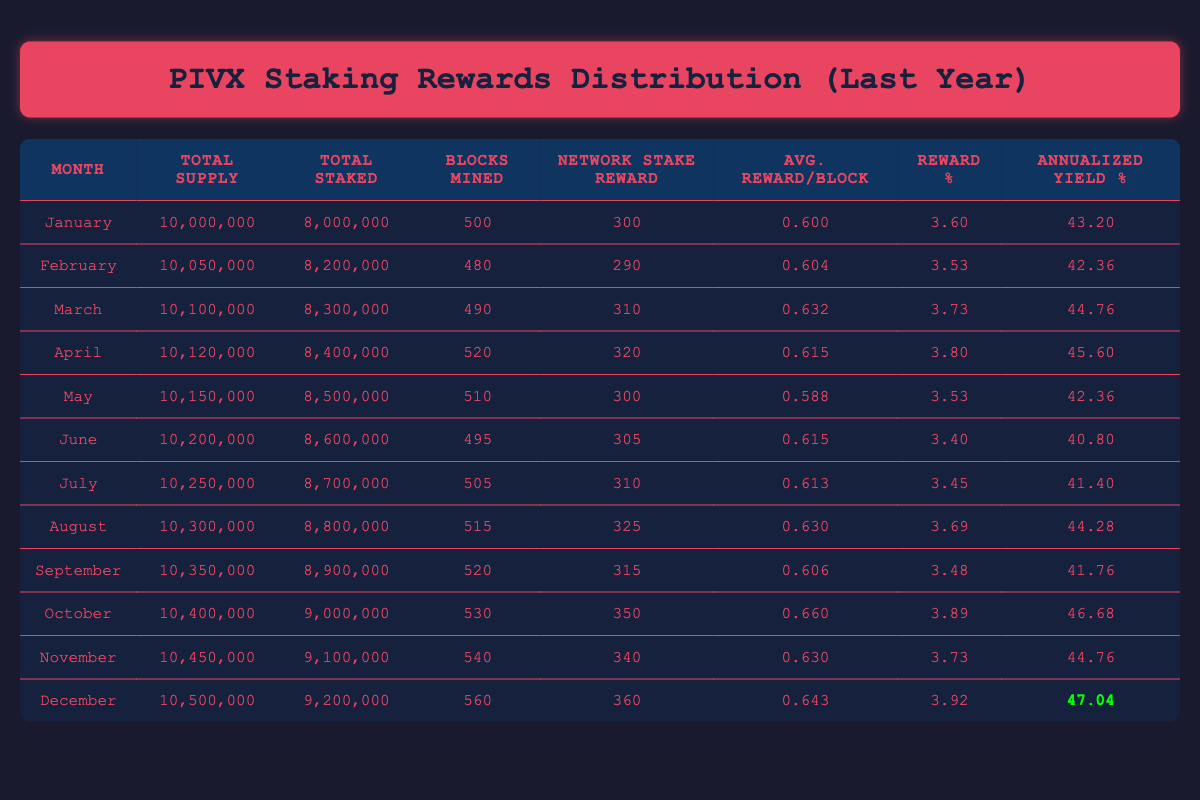What was the total supply of PIVX in December? Referring to the table, the total supply for December is directly listed under the "Total Supply" column, which shows 10,500,000.
Answer: 10,500,000 In which month did PIVX have the highest average reward per block? By checking the "Avg. Reward/Block" column for each month, October has the highest value of 0.660.
Answer: October What is the average annualized yield across all months? To find this, sum the "Annualized Yield %" values: 43.20 + 42.36 + 44.76 + 45.60 + 42.36 + 40.80 + 41.40 + 44.28 + 41.76 + 46.68 + 44.76 + 47.04 = 513.36. Then divide by 12 to get the average: 513.36 / 12 = 42.78.
Answer: 42.78 Did the network stake reward decrease from January to February? In January, the network stake reward was 300, while in February, it was 290. Therefore, it did decrease from one month to the next.
Answer: Yes How many blocks were mined in the month with the lowest reward percentage? The lowest "Reward %" value is in June, with 3.40%. In that same month, 495 blocks were mined.
Answer: 495 Which month had the highest total staked amount? The "Total Staked" column shows a steady increase throughout the year, and December has the highest amount at 9,200,000.
Answer: December What is the difference in total supply between January and December? The total supply in January is 10,000,000 and in December is 10,500,000. Therefore, the difference is 10,500,000 - 10,000,000 = 500,000.
Answer: 500,000 Did the average reward per block increase from April to August? In April, the average reward was 0.615, and in August, it was 0.630, indicating it did increase between those two months.
Answer: Yes How does the annualized yield in January compare to that in December? January's annualized yield is 43.20, and December's is 47.04. The annualized yield increased by 3.84 from January to December.
Answer: Increased by 3.84 What was the total stakes for the month with the highest network stake reward? The highest network stake reward was in October with a value of 350, and during that month, the total staked was 9,000,000.
Answer: 9,000,000 